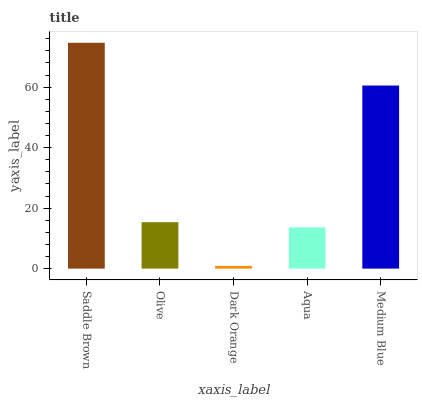Is Dark Orange the minimum?
Answer yes or no. Yes. Is Saddle Brown the maximum?
Answer yes or no. Yes. Is Olive the minimum?
Answer yes or no. No. Is Olive the maximum?
Answer yes or no. No. Is Saddle Brown greater than Olive?
Answer yes or no. Yes. Is Olive less than Saddle Brown?
Answer yes or no. Yes. Is Olive greater than Saddle Brown?
Answer yes or no. No. Is Saddle Brown less than Olive?
Answer yes or no. No. Is Olive the high median?
Answer yes or no. Yes. Is Olive the low median?
Answer yes or no. Yes. Is Aqua the high median?
Answer yes or no. No. Is Saddle Brown the low median?
Answer yes or no. No. 